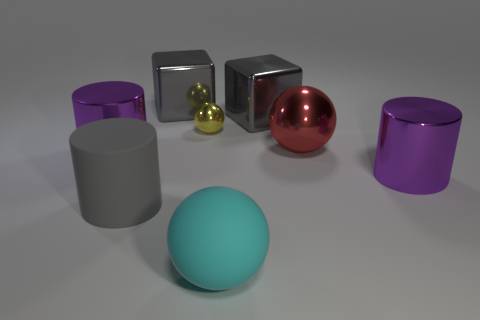Add 1 red matte cylinders. How many objects exist? 9 Subtract all cubes. How many objects are left? 6 Add 3 tiny metal balls. How many tiny metal balls exist? 4 Subtract 0 purple cubes. How many objects are left? 8 Subtract all gray metallic blocks. Subtract all yellow shiny things. How many objects are left? 5 Add 5 big rubber spheres. How many big rubber spheres are left? 6 